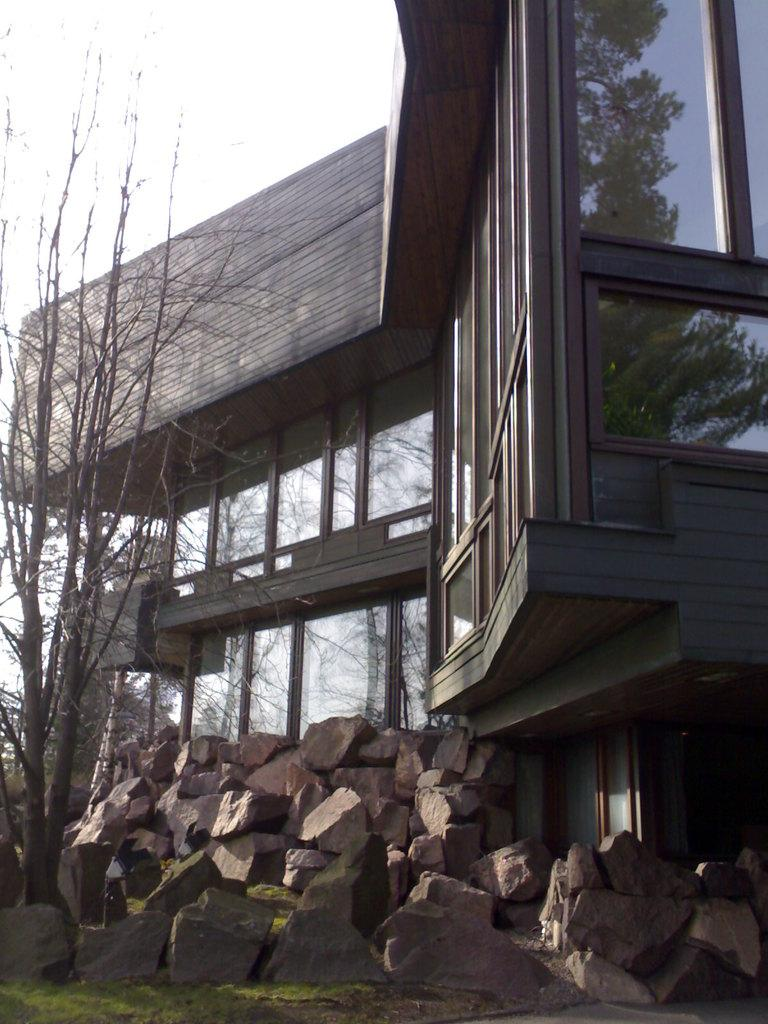What type of structure is present in the image? There is a building in the image. What type of natural elements can be seen in the image? There are many stones and a tree in the image. What type of position does the tree hold in the image? The tree does not hold a position in the image; it is a natural element. What type of apparel is the building wearing in the image? Buildings do not wear apparel; they are inanimate structures. What type of punishment is being administered to the stones in the image? There is no punishment being administered to the stones in the image; they are natural elements. 